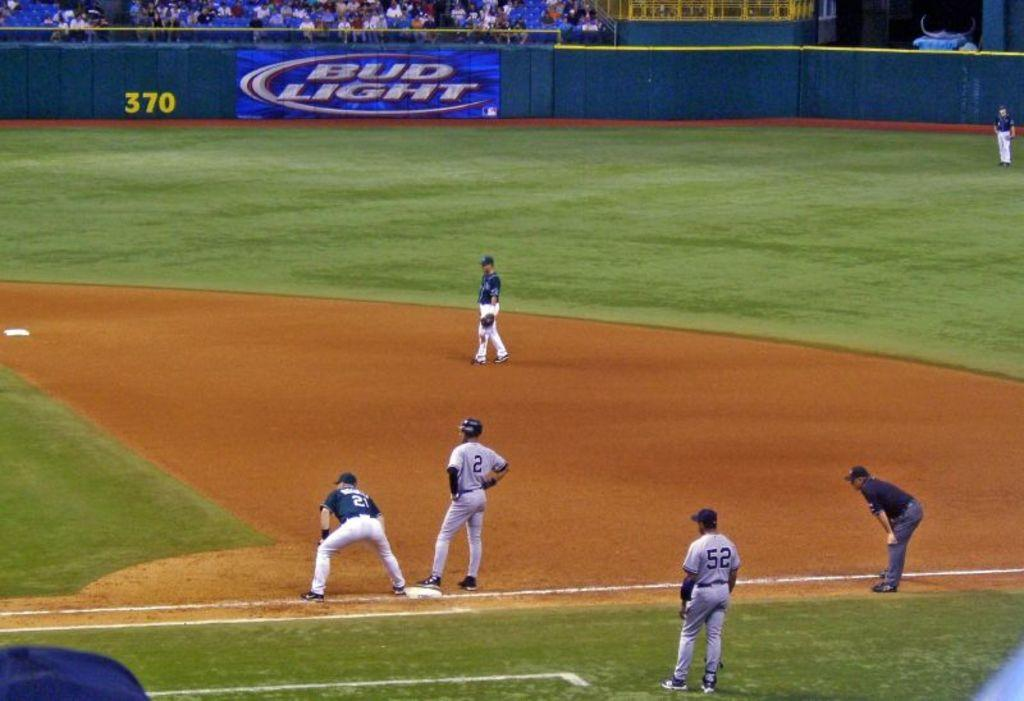<image>
Share a concise interpretation of the image provided. The number 2 baseball player is standing on first base and a big banner of Bud Light in on the outfield wall 